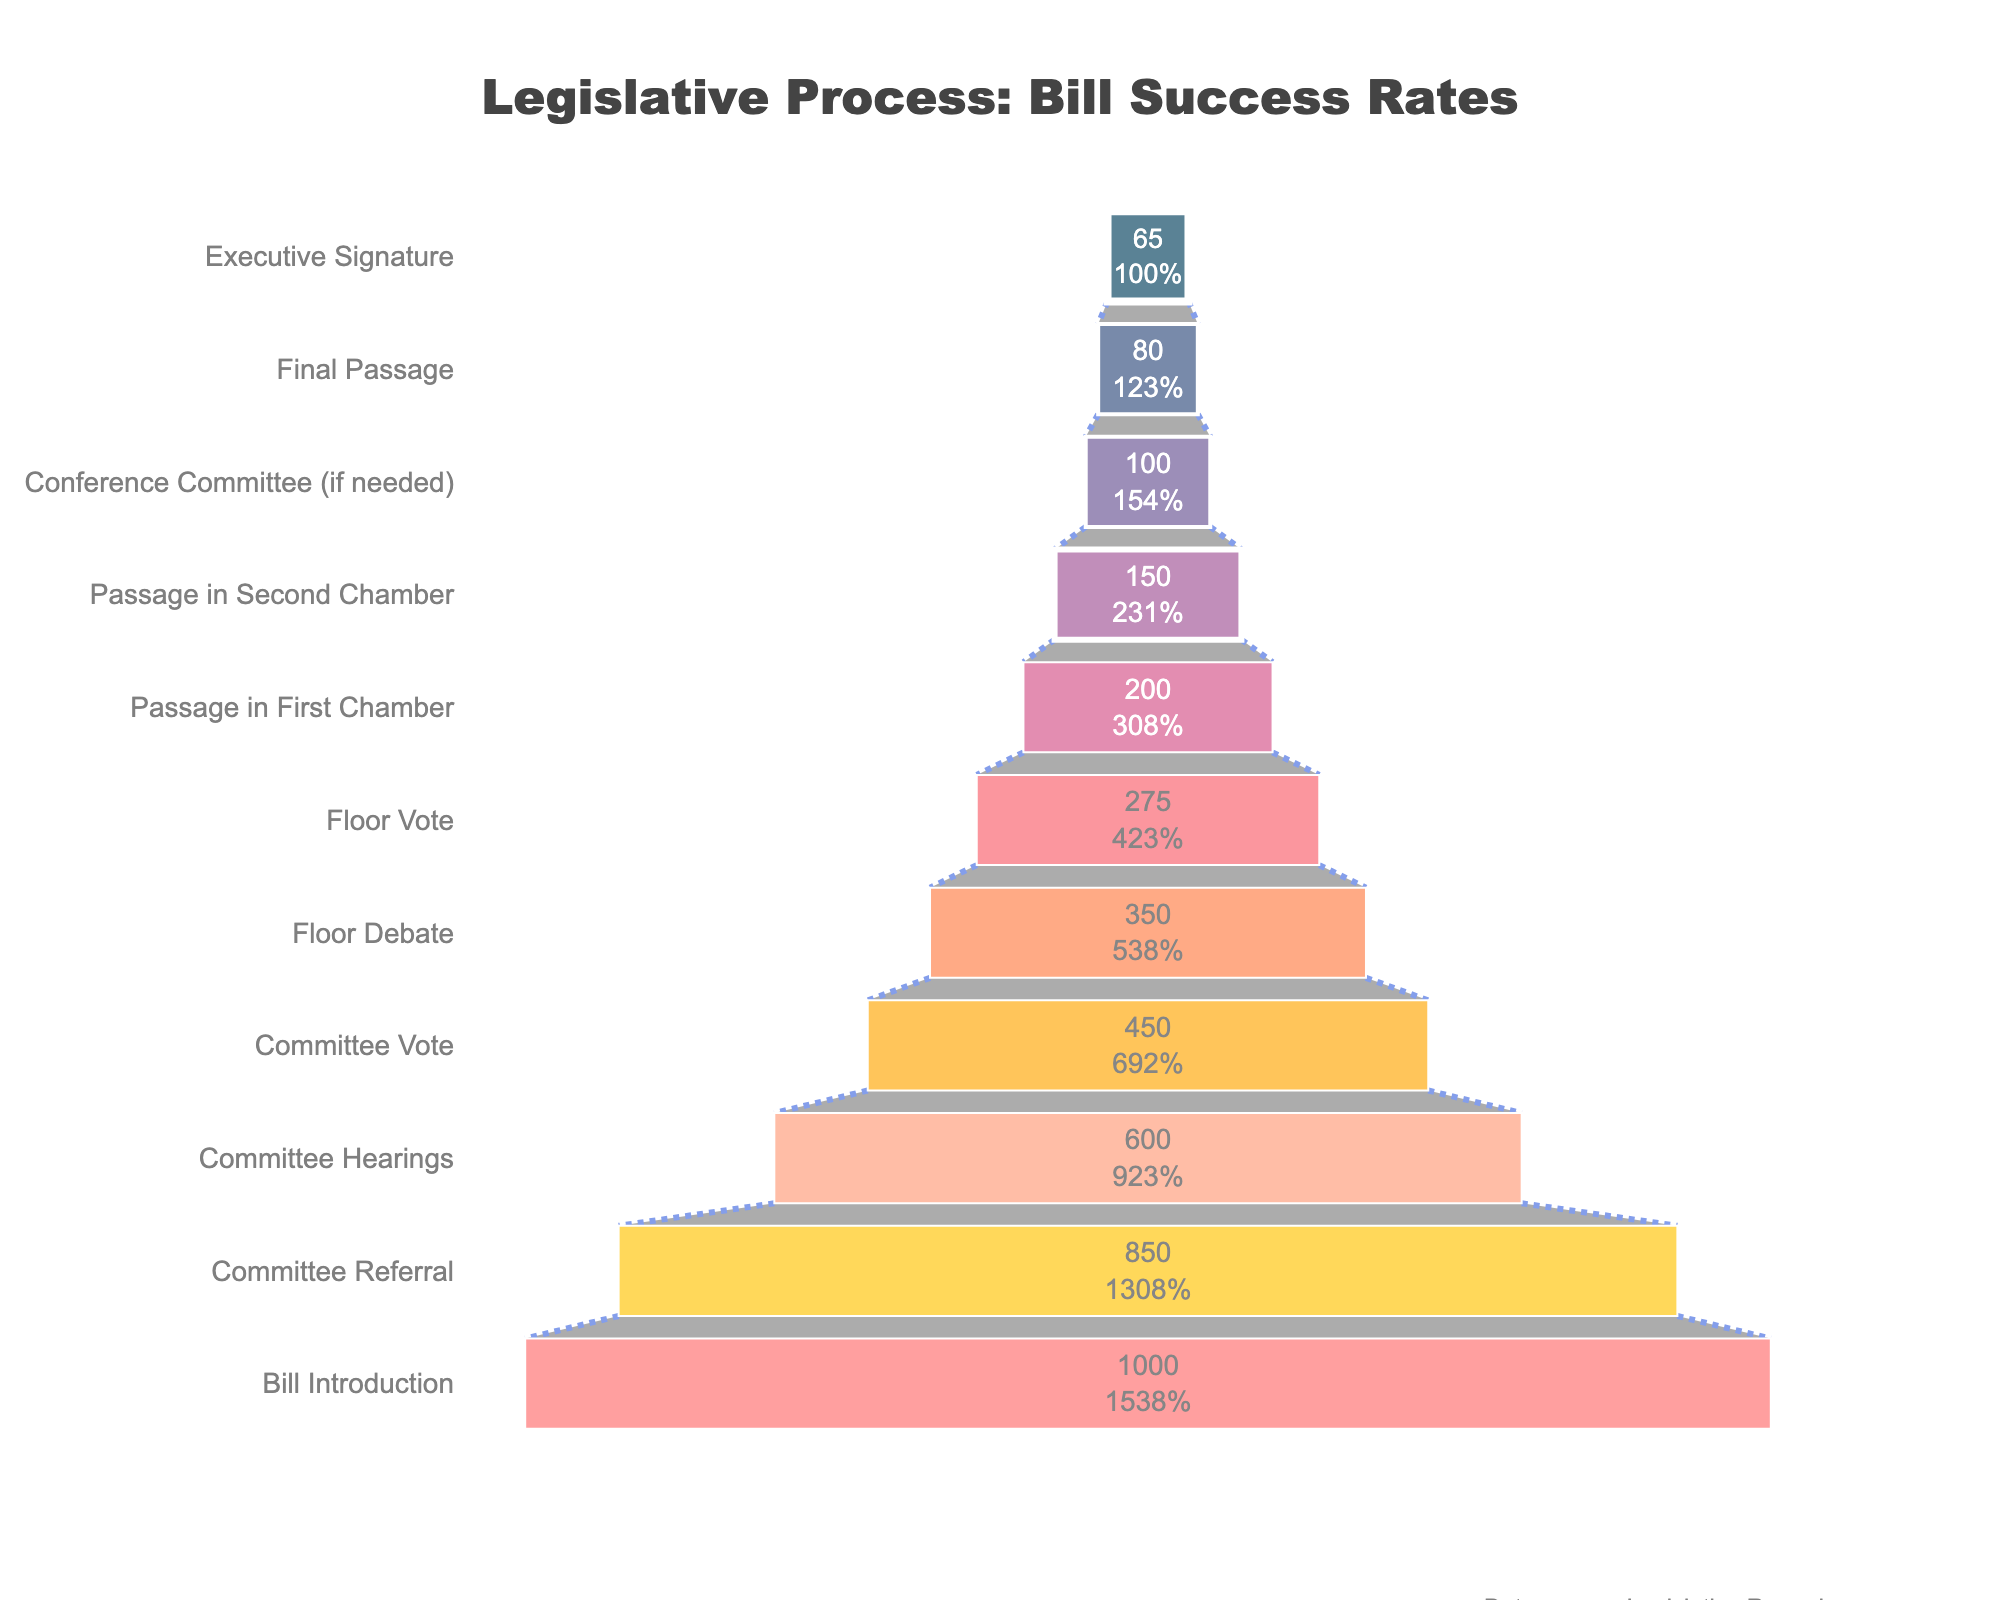How many bills reached the Executive Signature stage? To find out how many bills reached the Executive Signature stage, look at the corresponding value on the funnel chart. The bar labeled "Executive Signature" is the final stage, indicating 65 bills reached this stage.
Answer: 65 How many bills were introduced initially, and how does this compare with the number of bills that received the Executive Signature? The figure shows 1000 bills were introduced at the "Bill Introduction" stage, and 65 bills reached the "Executive Signature" stage. The difference is 1000 - 65 = 935 bills.
Answer: 935 What percentage of bills that passed the first chamber also passed the second chamber? The number of bills that passed the first chamber is 200, while the number that passed the second chamber is 150. The percentage is calculated as (150 / 200) * 100 = 75%.
Answer: 75% Which legislative stage saw the most significant drop in the number of bills advancing to the next stage? The figure must be examined to find the stage with the largest numerical decrease between consecutive stages. The greatest drop is between the "Committee Hearings" (600 bills) and "Committee Vote" (450 bills), with a difference of 150 bills.
Answer: Committee Hearings to Committee Vote What proportion of bills introduced made it to the final stage of the legislative process? The initial number of bills is 1000, and the number that made it to the "Executive Signature" stage is 65. The proportion is (65 / 1000) * 100 = 6.5%.
Answer: 6.5% How many bills made it past the floor vote stage but did not receive the executive signature? The number of bills at the "Floor Vote" stage is 275, and those that received the "Executive Signature" are 65. The number of bills making it past the "Floor Vote" stage but not receiving the "Executive Signature" is 275 - 65 = 210.
Answer: 210 What percentage of bills that were referred to a committee were ultimately passed in the first chamber? The number of bills referred to a committee is 850, and the number passed in the first chamber is 200. The percentage is (200 / 850) * 100 = 23.5%.
Answer: 23.5% Identify the stage with the highest retention rate of bills from the previous stage. The retention rate is calculated by comparing the number of bills in successive stages. The highest retention rate, based on percentage, is between "Passage in Second Chamber" (150) and "Conference Committee (if needed)" (100). Retention is (100 / 150) * 100% = 66.7%.
Answer: Passage in Second Chamber to Conference Committee Comparing initial and final stages, how does the success rate differ between bills that reached committee hearings versus those that ultimately received executive signatures? The number of bills at "Committee Hearings" is 600, and those that received "Executive Signature" are 65. The success rate for "Committee Hearings" to "Executive Signature" is (65 / 600) * 100 = 10.83%. Comparing this to 6.5% overall success rate from initial proposal to executive signature.
Answer: 10.83% 